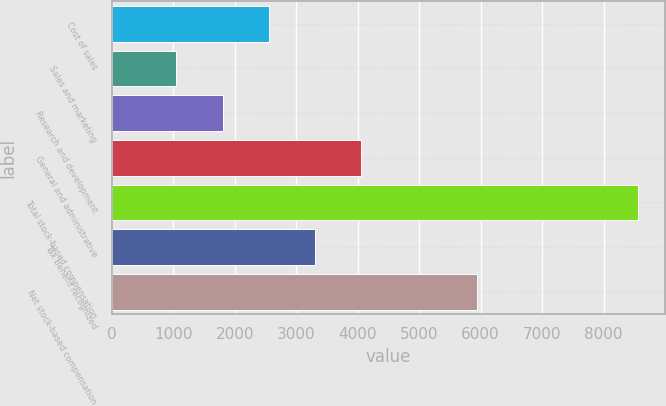Convert chart to OTSL. <chart><loc_0><loc_0><loc_500><loc_500><bar_chart><fcel>Cost of sales<fcel>Sales and marketing<fcel>Research and development<fcel>General and administrative<fcel>Total stock-based compensation<fcel>Tax benefit recognized<fcel>Net stock-based compensation<nl><fcel>2554.6<fcel>1052<fcel>1803.3<fcel>4057.2<fcel>8565<fcel>3305.9<fcel>5936<nl></chart> 